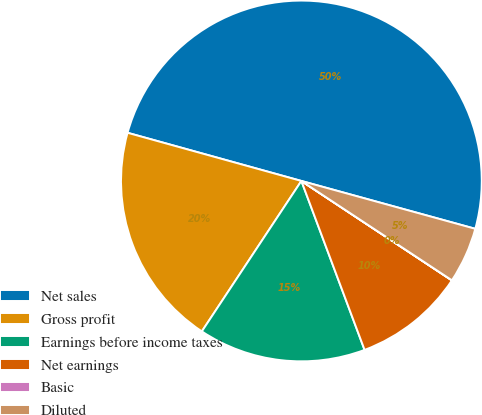<chart> <loc_0><loc_0><loc_500><loc_500><pie_chart><fcel>Net sales<fcel>Gross profit<fcel>Earnings before income taxes<fcel>Net earnings<fcel>Basic<fcel>Diluted<nl><fcel>49.97%<fcel>20.0%<fcel>15.0%<fcel>10.01%<fcel>0.01%<fcel>5.01%<nl></chart> 